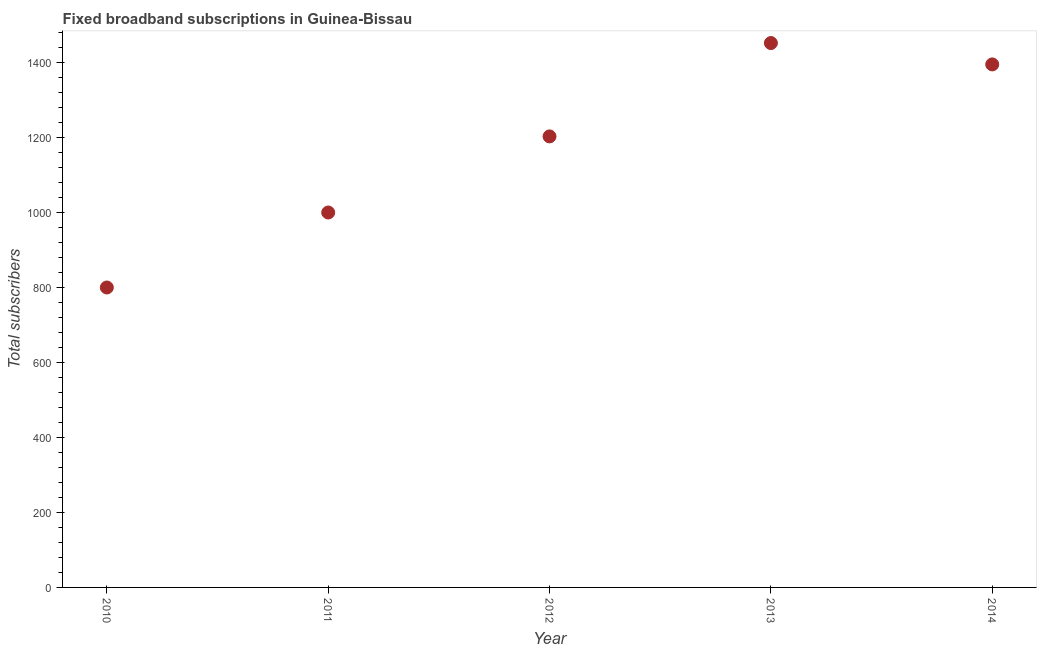What is the total number of fixed broadband subscriptions in 2011?
Your answer should be very brief. 1000. Across all years, what is the maximum total number of fixed broadband subscriptions?
Provide a short and direct response. 1452. Across all years, what is the minimum total number of fixed broadband subscriptions?
Keep it short and to the point. 800. In which year was the total number of fixed broadband subscriptions maximum?
Make the answer very short. 2013. In which year was the total number of fixed broadband subscriptions minimum?
Offer a terse response. 2010. What is the sum of the total number of fixed broadband subscriptions?
Offer a terse response. 5850. What is the difference between the total number of fixed broadband subscriptions in 2012 and 2014?
Your answer should be compact. -192. What is the average total number of fixed broadband subscriptions per year?
Make the answer very short. 1170. What is the median total number of fixed broadband subscriptions?
Provide a succinct answer. 1203. In how many years, is the total number of fixed broadband subscriptions greater than 80 ?
Offer a very short reply. 5. What is the ratio of the total number of fixed broadband subscriptions in 2010 to that in 2011?
Provide a short and direct response. 0.8. Is the total number of fixed broadband subscriptions in 2011 less than that in 2014?
Keep it short and to the point. Yes. What is the difference between the highest and the lowest total number of fixed broadband subscriptions?
Provide a succinct answer. 652. Does the total number of fixed broadband subscriptions monotonically increase over the years?
Provide a short and direct response. No. How many dotlines are there?
Provide a short and direct response. 1. Are the values on the major ticks of Y-axis written in scientific E-notation?
Offer a terse response. No. What is the title of the graph?
Give a very brief answer. Fixed broadband subscriptions in Guinea-Bissau. What is the label or title of the Y-axis?
Offer a terse response. Total subscribers. What is the Total subscribers in 2010?
Your answer should be very brief. 800. What is the Total subscribers in 2012?
Offer a very short reply. 1203. What is the Total subscribers in 2013?
Offer a very short reply. 1452. What is the Total subscribers in 2014?
Offer a very short reply. 1395. What is the difference between the Total subscribers in 2010 and 2011?
Keep it short and to the point. -200. What is the difference between the Total subscribers in 2010 and 2012?
Provide a short and direct response. -403. What is the difference between the Total subscribers in 2010 and 2013?
Offer a very short reply. -652. What is the difference between the Total subscribers in 2010 and 2014?
Keep it short and to the point. -595. What is the difference between the Total subscribers in 2011 and 2012?
Offer a very short reply. -203. What is the difference between the Total subscribers in 2011 and 2013?
Make the answer very short. -452. What is the difference between the Total subscribers in 2011 and 2014?
Offer a terse response. -395. What is the difference between the Total subscribers in 2012 and 2013?
Your answer should be compact. -249. What is the difference between the Total subscribers in 2012 and 2014?
Offer a terse response. -192. What is the difference between the Total subscribers in 2013 and 2014?
Provide a succinct answer. 57. What is the ratio of the Total subscribers in 2010 to that in 2012?
Ensure brevity in your answer.  0.67. What is the ratio of the Total subscribers in 2010 to that in 2013?
Give a very brief answer. 0.55. What is the ratio of the Total subscribers in 2010 to that in 2014?
Provide a short and direct response. 0.57. What is the ratio of the Total subscribers in 2011 to that in 2012?
Offer a very short reply. 0.83. What is the ratio of the Total subscribers in 2011 to that in 2013?
Offer a very short reply. 0.69. What is the ratio of the Total subscribers in 2011 to that in 2014?
Your answer should be compact. 0.72. What is the ratio of the Total subscribers in 2012 to that in 2013?
Your answer should be compact. 0.83. What is the ratio of the Total subscribers in 2012 to that in 2014?
Offer a terse response. 0.86. What is the ratio of the Total subscribers in 2013 to that in 2014?
Your response must be concise. 1.04. 